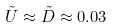<formula> <loc_0><loc_0><loc_500><loc_500>\tilde { U } \approx \tilde { D } \approx 0 . 0 3</formula> 